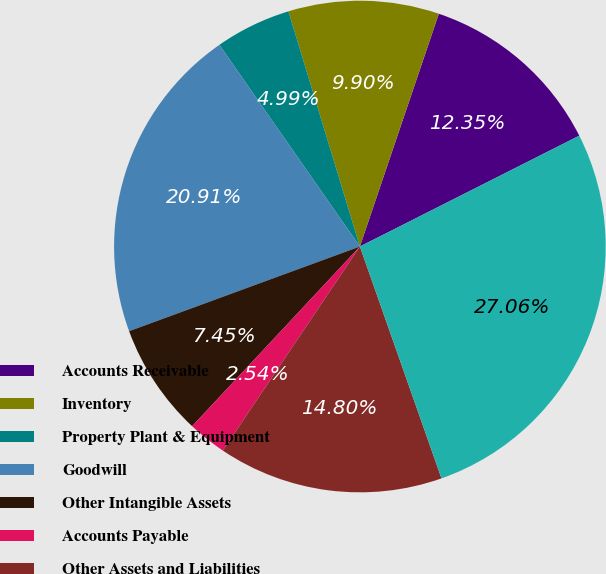Convert chart. <chart><loc_0><loc_0><loc_500><loc_500><pie_chart><fcel>Accounts Receivable<fcel>Inventory<fcel>Property Plant & Equipment<fcel>Goodwill<fcel>Other Intangible Assets<fcel>Accounts Payable<fcel>Other Assets and Liabilities<fcel>Net Cash Consideration<nl><fcel>12.35%<fcel>9.9%<fcel>4.99%<fcel>20.91%<fcel>7.45%<fcel>2.54%<fcel>14.8%<fcel>27.06%<nl></chart> 